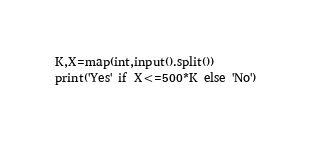<code> <loc_0><loc_0><loc_500><loc_500><_Python_>K,X=map(int,input().split())
print('Yes' if X<=500*K else 'No')</code> 